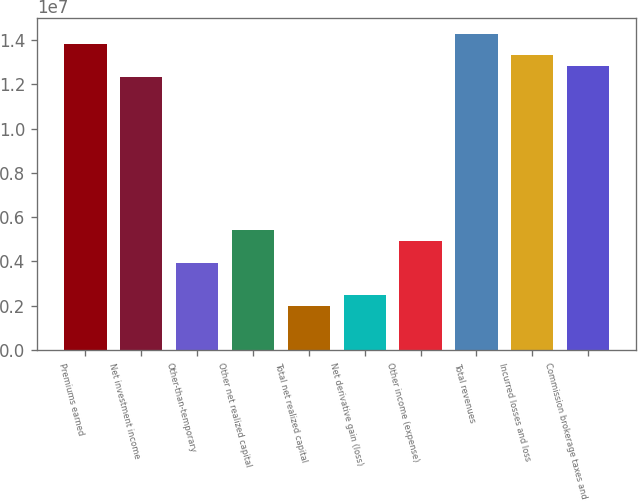<chart> <loc_0><loc_0><loc_500><loc_500><bar_chart><fcel>Premiums earned<fcel>Net investment income<fcel>Other-than-temporary<fcel>Other net realized capital<fcel>Total net realized capital<fcel>Net derivative gain (loss)<fcel>Other income (expense)<fcel>Total revenues<fcel>Incurred losses and loss<fcel>Commission brokerage taxes and<nl><fcel>1.37981e+07<fcel>1.23198e+07<fcel>3.94233e+06<fcel>5.4207e+06<fcel>1.97116e+06<fcel>2.46395e+06<fcel>4.92791e+06<fcel>1.42909e+07<fcel>1.33053e+07<fcel>1.28126e+07<nl></chart> 